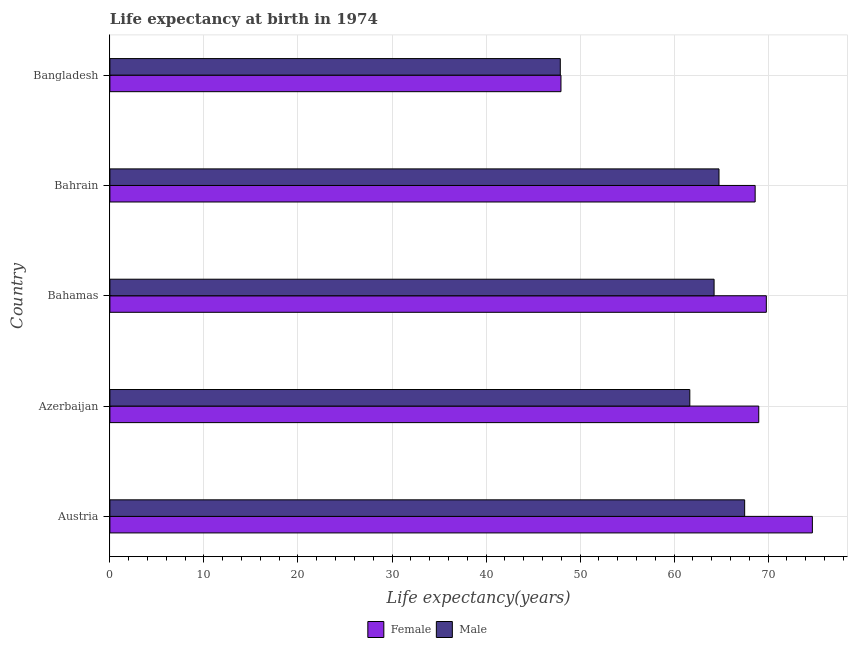How many groups of bars are there?
Provide a succinct answer. 5. Are the number of bars per tick equal to the number of legend labels?
Your response must be concise. Yes. Are the number of bars on each tick of the Y-axis equal?
Keep it short and to the point. Yes. How many bars are there on the 1st tick from the top?
Your answer should be very brief. 2. How many bars are there on the 2nd tick from the bottom?
Your answer should be very brief. 2. What is the label of the 2nd group of bars from the top?
Offer a very short reply. Bahrain. What is the life expectancy(male) in Bahrain?
Give a very brief answer. 64.77. Across all countries, what is the maximum life expectancy(male)?
Offer a very short reply. 67.5. Across all countries, what is the minimum life expectancy(male)?
Give a very brief answer. 47.9. In which country was the life expectancy(female) maximum?
Keep it short and to the point. Austria. What is the total life expectancy(female) in the graph?
Make the answer very short. 330.09. What is the difference between the life expectancy(male) in Azerbaijan and that in Bahamas?
Provide a succinct answer. -2.58. What is the difference between the life expectancy(female) in Bangladesh and the life expectancy(male) in Austria?
Make the answer very short. -19.53. What is the average life expectancy(male) per country?
Your response must be concise. 61.22. What is the difference between the life expectancy(female) and life expectancy(male) in Bahrain?
Offer a very short reply. 3.85. What is the ratio of the life expectancy(female) in Austria to that in Bangladesh?
Provide a short and direct response. 1.56. Is the life expectancy(female) in Bahamas less than that in Bahrain?
Offer a very short reply. No. What is the difference between the highest and the second highest life expectancy(female)?
Ensure brevity in your answer.  4.9. What is the difference between the highest and the lowest life expectancy(male)?
Your answer should be compact. 19.6. Is the sum of the life expectancy(male) in Austria and Bahamas greater than the maximum life expectancy(female) across all countries?
Provide a short and direct response. Yes. What does the 2nd bar from the top in Bahrain represents?
Keep it short and to the point. Female. How many bars are there?
Ensure brevity in your answer.  10. Are all the bars in the graph horizontal?
Provide a succinct answer. Yes. What is the difference between two consecutive major ticks on the X-axis?
Your answer should be compact. 10. Does the graph contain any zero values?
Your answer should be very brief. No. Does the graph contain grids?
Your answer should be compact. Yes. What is the title of the graph?
Provide a succinct answer. Life expectancy at birth in 1974. Does "Investment in Telecom" appear as one of the legend labels in the graph?
Ensure brevity in your answer.  No. What is the label or title of the X-axis?
Make the answer very short. Life expectancy(years). What is the Life expectancy(years) of Female in Austria?
Your answer should be compact. 74.7. What is the Life expectancy(years) in Male in Austria?
Offer a terse response. 67.5. What is the Life expectancy(years) in Female in Azerbaijan?
Give a very brief answer. 69. What is the Life expectancy(years) of Male in Azerbaijan?
Make the answer very short. 61.67. What is the Life expectancy(years) of Female in Bahamas?
Your answer should be very brief. 69.8. What is the Life expectancy(years) of Male in Bahamas?
Offer a very short reply. 64.25. What is the Life expectancy(years) in Female in Bahrain?
Offer a very short reply. 68.62. What is the Life expectancy(years) of Male in Bahrain?
Your answer should be very brief. 64.77. What is the Life expectancy(years) of Female in Bangladesh?
Provide a short and direct response. 47.97. What is the Life expectancy(years) in Male in Bangladesh?
Offer a very short reply. 47.9. Across all countries, what is the maximum Life expectancy(years) in Female?
Make the answer very short. 74.7. Across all countries, what is the maximum Life expectancy(years) of Male?
Give a very brief answer. 67.5. Across all countries, what is the minimum Life expectancy(years) of Female?
Ensure brevity in your answer.  47.97. Across all countries, what is the minimum Life expectancy(years) of Male?
Offer a very short reply. 47.9. What is the total Life expectancy(years) of Female in the graph?
Offer a very short reply. 330.09. What is the total Life expectancy(years) in Male in the graph?
Ensure brevity in your answer.  306.08. What is the difference between the Life expectancy(years) in Female in Austria and that in Azerbaijan?
Your answer should be compact. 5.7. What is the difference between the Life expectancy(years) of Male in Austria and that in Azerbaijan?
Ensure brevity in your answer.  5.83. What is the difference between the Life expectancy(years) in Female in Austria and that in Bahamas?
Offer a terse response. 4.9. What is the difference between the Life expectancy(years) of Male in Austria and that in Bahamas?
Make the answer very short. 3.25. What is the difference between the Life expectancy(years) of Female in Austria and that in Bahrain?
Your answer should be compact. 6.08. What is the difference between the Life expectancy(years) in Male in Austria and that in Bahrain?
Your answer should be compact. 2.73. What is the difference between the Life expectancy(years) in Female in Austria and that in Bangladesh?
Provide a succinct answer. 26.73. What is the difference between the Life expectancy(years) in Male in Austria and that in Bangladesh?
Your answer should be very brief. 19.61. What is the difference between the Life expectancy(years) in Female in Azerbaijan and that in Bahamas?
Give a very brief answer. -0.81. What is the difference between the Life expectancy(years) of Male in Azerbaijan and that in Bahamas?
Provide a succinct answer. -2.58. What is the difference between the Life expectancy(years) of Female in Azerbaijan and that in Bahrain?
Provide a succinct answer. 0.38. What is the difference between the Life expectancy(years) of Male in Azerbaijan and that in Bahrain?
Provide a short and direct response. -3.1. What is the difference between the Life expectancy(years) of Female in Azerbaijan and that in Bangladesh?
Your answer should be very brief. 21.03. What is the difference between the Life expectancy(years) in Male in Azerbaijan and that in Bangladesh?
Keep it short and to the point. 13.77. What is the difference between the Life expectancy(years) of Female in Bahamas and that in Bahrain?
Give a very brief answer. 1.19. What is the difference between the Life expectancy(years) in Male in Bahamas and that in Bahrain?
Keep it short and to the point. -0.52. What is the difference between the Life expectancy(years) of Female in Bahamas and that in Bangladesh?
Your answer should be compact. 21.84. What is the difference between the Life expectancy(years) of Male in Bahamas and that in Bangladesh?
Ensure brevity in your answer.  16.35. What is the difference between the Life expectancy(years) of Female in Bahrain and that in Bangladesh?
Your answer should be compact. 20.65. What is the difference between the Life expectancy(years) in Male in Bahrain and that in Bangladesh?
Give a very brief answer. 16.88. What is the difference between the Life expectancy(years) of Female in Austria and the Life expectancy(years) of Male in Azerbaijan?
Offer a terse response. 13.03. What is the difference between the Life expectancy(years) in Female in Austria and the Life expectancy(years) in Male in Bahamas?
Provide a short and direct response. 10.45. What is the difference between the Life expectancy(years) in Female in Austria and the Life expectancy(years) in Male in Bahrain?
Keep it short and to the point. 9.93. What is the difference between the Life expectancy(years) of Female in Austria and the Life expectancy(years) of Male in Bangladesh?
Ensure brevity in your answer.  26.8. What is the difference between the Life expectancy(years) of Female in Azerbaijan and the Life expectancy(years) of Male in Bahamas?
Your answer should be very brief. 4.75. What is the difference between the Life expectancy(years) of Female in Azerbaijan and the Life expectancy(years) of Male in Bahrain?
Make the answer very short. 4.23. What is the difference between the Life expectancy(years) of Female in Azerbaijan and the Life expectancy(years) of Male in Bangladesh?
Give a very brief answer. 21.1. What is the difference between the Life expectancy(years) in Female in Bahamas and the Life expectancy(years) in Male in Bahrain?
Provide a short and direct response. 5.03. What is the difference between the Life expectancy(years) in Female in Bahamas and the Life expectancy(years) in Male in Bangladesh?
Ensure brevity in your answer.  21.91. What is the difference between the Life expectancy(years) of Female in Bahrain and the Life expectancy(years) of Male in Bangladesh?
Your answer should be very brief. 20.72. What is the average Life expectancy(years) in Female per country?
Ensure brevity in your answer.  66.02. What is the average Life expectancy(years) of Male per country?
Keep it short and to the point. 61.22. What is the difference between the Life expectancy(years) in Female and Life expectancy(years) in Male in Austria?
Offer a terse response. 7.2. What is the difference between the Life expectancy(years) in Female and Life expectancy(years) in Male in Azerbaijan?
Your answer should be compact. 7.33. What is the difference between the Life expectancy(years) in Female and Life expectancy(years) in Male in Bahamas?
Provide a succinct answer. 5.55. What is the difference between the Life expectancy(years) of Female and Life expectancy(years) of Male in Bahrain?
Provide a succinct answer. 3.85. What is the difference between the Life expectancy(years) of Female and Life expectancy(years) of Male in Bangladesh?
Give a very brief answer. 0.07. What is the ratio of the Life expectancy(years) in Female in Austria to that in Azerbaijan?
Your answer should be very brief. 1.08. What is the ratio of the Life expectancy(years) of Male in Austria to that in Azerbaijan?
Give a very brief answer. 1.09. What is the ratio of the Life expectancy(years) of Female in Austria to that in Bahamas?
Ensure brevity in your answer.  1.07. What is the ratio of the Life expectancy(years) of Male in Austria to that in Bahamas?
Offer a very short reply. 1.05. What is the ratio of the Life expectancy(years) of Female in Austria to that in Bahrain?
Keep it short and to the point. 1.09. What is the ratio of the Life expectancy(years) of Male in Austria to that in Bahrain?
Your answer should be compact. 1.04. What is the ratio of the Life expectancy(years) of Female in Austria to that in Bangladesh?
Provide a short and direct response. 1.56. What is the ratio of the Life expectancy(years) of Male in Austria to that in Bangladesh?
Your response must be concise. 1.41. What is the ratio of the Life expectancy(years) of Female in Azerbaijan to that in Bahamas?
Offer a very short reply. 0.99. What is the ratio of the Life expectancy(years) of Male in Azerbaijan to that in Bahamas?
Your answer should be compact. 0.96. What is the ratio of the Life expectancy(years) of Female in Azerbaijan to that in Bahrain?
Offer a very short reply. 1.01. What is the ratio of the Life expectancy(years) of Male in Azerbaijan to that in Bahrain?
Make the answer very short. 0.95. What is the ratio of the Life expectancy(years) of Female in Azerbaijan to that in Bangladesh?
Offer a very short reply. 1.44. What is the ratio of the Life expectancy(years) in Male in Azerbaijan to that in Bangladesh?
Make the answer very short. 1.29. What is the ratio of the Life expectancy(years) of Female in Bahamas to that in Bahrain?
Your response must be concise. 1.02. What is the ratio of the Life expectancy(years) in Female in Bahamas to that in Bangladesh?
Your response must be concise. 1.46. What is the ratio of the Life expectancy(years) in Male in Bahamas to that in Bangladesh?
Offer a very short reply. 1.34. What is the ratio of the Life expectancy(years) in Female in Bahrain to that in Bangladesh?
Provide a short and direct response. 1.43. What is the ratio of the Life expectancy(years) in Male in Bahrain to that in Bangladesh?
Provide a short and direct response. 1.35. What is the difference between the highest and the second highest Life expectancy(years) of Female?
Provide a succinct answer. 4.9. What is the difference between the highest and the second highest Life expectancy(years) in Male?
Your answer should be compact. 2.73. What is the difference between the highest and the lowest Life expectancy(years) of Female?
Give a very brief answer. 26.73. What is the difference between the highest and the lowest Life expectancy(years) of Male?
Your answer should be compact. 19.61. 